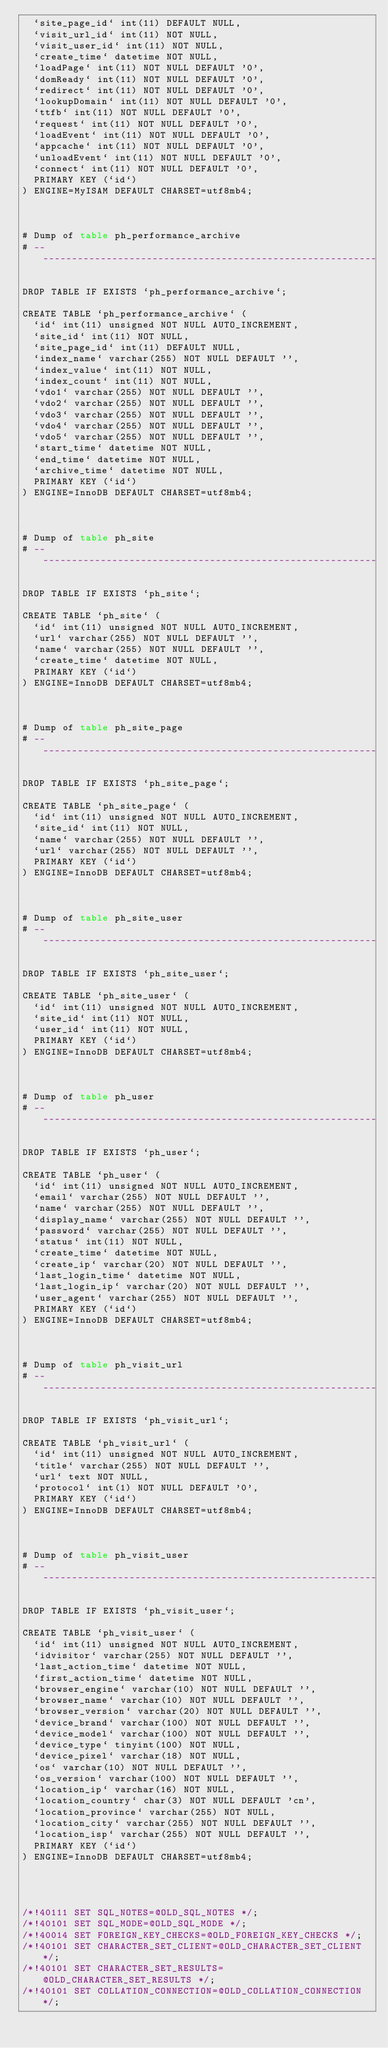<code> <loc_0><loc_0><loc_500><loc_500><_SQL_>  `site_page_id` int(11) DEFAULT NULL,
  `visit_url_id` int(11) NOT NULL,
  `visit_user_id` int(11) NOT NULL,
  `create_time` datetime NOT NULL,
  `loadPage` int(11) NOT NULL DEFAULT '0',
  `domReady` int(11) NOT NULL DEFAULT '0',
  `redirect` int(11) NOT NULL DEFAULT '0',
  `lookupDomain` int(11) NOT NULL DEFAULT '0',
  `ttfb` int(11) NOT NULL DEFAULT '0',
  `request` int(11) NOT NULL DEFAULT '0',
  `loadEvent` int(11) NOT NULL DEFAULT '0',
  `appcache` int(11) NOT NULL DEFAULT '0',
  `unloadEvent` int(11) NOT NULL DEFAULT '0',
  `connect` int(11) NOT NULL DEFAULT '0',
  PRIMARY KEY (`id`)
) ENGINE=MyISAM DEFAULT CHARSET=utf8mb4;



# Dump of table ph_performance_archive
# ------------------------------------------------------------

DROP TABLE IF EXISTS `ph_performance_archive`;

CREATE TABLE `ph_performance_archive` (
  `id` int(11) unsigned NOT NULL AUTO_INCREMENT,
  `site_id` int(11) NOT NULL,
  `site_page_id` int(11) DEFAULT NULL,
  `index_name` varchar(255) NOT NULL DEFAULT '',
  `index_value` int(11) NOT NULL,
  `index_count` int(11) NOT NULL,
  `vdo1` varchar(255) NOT NULL DEFAULT '',
  `vdo2` varchar(255) NOT NULL DEFAULT '',
  `vdo3` varchar(255) NOT NULL DEFAULT '',
  `vdo4` varchar(255) NOT NULL DEFAULT '',
  `vdo5` varchar(255) NOT NULL DEFAULT '',
  `start_time` datetime NOT NULL,
  `end_time` datetime NOT NULL,
  `archive_time` datetime NOT NULL,
  PRIMARY KEY (`id`)
) ENGINE=InnoDB DEFAULT CHARSET=utf8mb4;



# Dump of table ph_site
# ------------------------------------------------------------

DROP TABLE IF EXISTS `ph_site`;

CREATE TABLE `ph_site` (
  `id` int(11) unsigned NOT NULL AUTO_INCREMENT,
  `url` varchar(255) NOT NULL DEFAULT '',
  `name` varchar(255) NOT NULL DEFAULT '',
  `create_time` datetime NOT NULL,
  PRIMARY KEY (`id`)
) ENGINE=InnoDB DEFAULT CHARSET=utf8mb4;



# Dump of table ph_site_page
# ------------------------------------------------------------

DROP TABLE IF EXISTS `ph_site_page`;

CREATE TABLE `ph_site_page` (
  `id` int(11) unsigned NOT NULL AUTO_INCREMENT,
  `site_id` int(11) NOT NULL,
  `name` varchar(255) NOT NULL DEFAULT '',
  `url` varchar(255) NOT NULL DEFAULT '',
  PRIMARY KEY (`id`)
) ENGINE=InnoDB DEFAULT CHARSET=utf8mb4;



# Dump of table ph_site_user
# ------------------------------------------------------------

DROP TABLE IF EXISTS `ph_site_user`;

CREATE TABLE `ph_site_user` (
  `id` int(11) unsigned NOT NULL AUTO_INCREMENT,
  `site_id` int(11) NOT NULL,
  `user_id` int(11) NOT NULL,
  PRIMARY KEY (`id`)
) ENGINE=InnoDB DEFAULT CHARSET=utf8mb4;



# Dump of table ph_user
# ------------------------------------------------------------

DROP TABLE IF EXISTS `ph_user`;

CREATE TABLE `ph_user` (
  `id` int(11) unsigned NOT NULL AUTO_INCREMENT,
  `email` varchar(255) NOT NULL DEFAULT '',
  `name` varchar(255) NOT NULL DEFAULT '',
  `display_name` varchar(255) NOT NULL DEFAULT '',
  `password` varchar(255) NOT NULL DEFAULT '',
  `status` int(11) NOT NULL,
  `create_time` datetime NOT NULL,
  `create_ip` varchar(20) NOT NULL DEFAULT '',
  `last_login_time` datetime NOT NULL,
  `last_login_ip` varchar(20) NOT NULL DEFAULT '',
  `user_agent` varchar(255) NOT NULL DEFAULT '',
  PRIMARY KEY (`id`)
) ENGINE=InnoDB DEFAULT CHARSET=utf8mb4;



# Dump of table ph_visit_url
# ------------------------------------------------------------

DROP TABLE IF EXISTS `ph_visit_url`;

CREATE TABLE `ph_visit_url` (
  `id` int(11) unsigned NOT NULL AUTO_INCREMENT,
  `title` varchar(255) NOT NULL DEFAULT '',
  `url` text NOT NULL,
  `protocol` int(1) NOT NULL DEFAULT '0',
  PRIMARY KEY (`id`)
) ENGINE=InnoDB DEFAULT CHARSET=utf8mb4;



# Dump of table ph_visit_user
# ------------------------------------------------------------

DROP TABLE IF EXISTS `ph_visit_user`;

CREATE TABLE `ph_visit_user` (
  `id` int(11) unsigned NOT NULL AUTO_INCREMENT,
  `idvisitor` varchar(255) NOT NULL DEFAULT '',
  `last_action_time` datetime NOT NULL,
  `first_action_time` datetime NOT NULL,
  `browser_engine` varchar(10) NOT NULL DEFAULT '',
  `browser_name` varchar(10) NOT NULL DEFAULT '',
  `browser_version` varchar(20) NOT NULL DEFAULT '',
  `device_brand` varchar(100) NOT NULL DEFAULT '',
  `device_model` varchar(100) NOT NULL DEFAULT '',
  `device_type` tinyint(100) NOT NULL,
  `device_pixel` varchar(18) NOT NULL,
  `os` varchar(10) NOT NULL DEFAULT '',
  `os_version` varchar(100) NOT NULL DEFAULT '',
  `location_ip` varchar(16) NOT NULL,
  `location_country` char(3) NOT NULL DEFAULT 'cn',
  `location_province` varchar(255) NOT NULL,
  `location_city` varchar(255) NOT NULL DEFAULT '',
  `location_isp` varchar(255) NOT NULL DEFAULT '',
  PRIMARY KEY (`id`)
) ENGINE=InnoDB DEFAULT CHARSET=utf8mb4;




/*!40111 SET SQL_NOTES=@OLD_SQL_NOTES */;
/*!40101 SET SQL_MODE=@OLD_SQL_MODE */;
/*!40014 SET FOREIGN_KEY_CHECKS=@OLD_FOREIGN_KEY_CHECKS */;
/*!40101 SET CHARACTER_SET_CLIENT=@OLD_CHARACTER_SET_CLIENT */;
/*!40101 SET CHARACTER_SET_RESULTS=@OLD_CHARACTER_SET_RESULTS */;
/*!40101 SET COLLATION_CONNECTION=@OLD_COLLATION_CONNECTION */;
</code> 